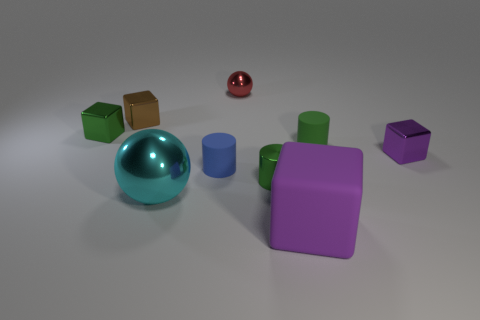What number of other things are there of the same material as the tiny brown block
Keep it short and to the point. 5. There is a small matte object that is to the right of the green shiny object that is on the right side of the tiny red metallic object; is there a tiny cylinder that is left of it?
Make the answer very short. Yes. There is a tiny green metal thing that is to the left of the small red shiny object; is it the same shape as the purple matte object?
Provide a succinct answer. Yes. Is the number of small green rubber things that are left of the big cyan ball less than the number of tiny red metal objects that are left of the large purple matte object?
Provide a short and direct response. Yes. What is the brown object made of?
Your answer should be very brief. Metal. Does the large rubber block have the same color as the tiny block to the right of the big ball?
Your response must be concise. Yes. There is a purple rubber cube; what number of green metal objects are in front of it?
Your answer should be compact. 0. Are there fewer large metallic balls that are behind the green shiny block than small yellow things?
Offer a terse response. No. The large metal ball is what color?
Offer a very short reply. Cyan. Do the tiny cube that is to the right of the red object and the large matte cube have the same color?
Your answer should be compact. Yes. 